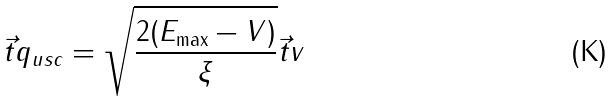Convert formula to latex. <formula><loc_0><loc_0><loc_500><loc_500>\vec { t } { q } _ { u s c } = \sqrt { \frac { 2 ( E _ { \max } - V ) } { \xi } } \vec { t } { v }</formula> 